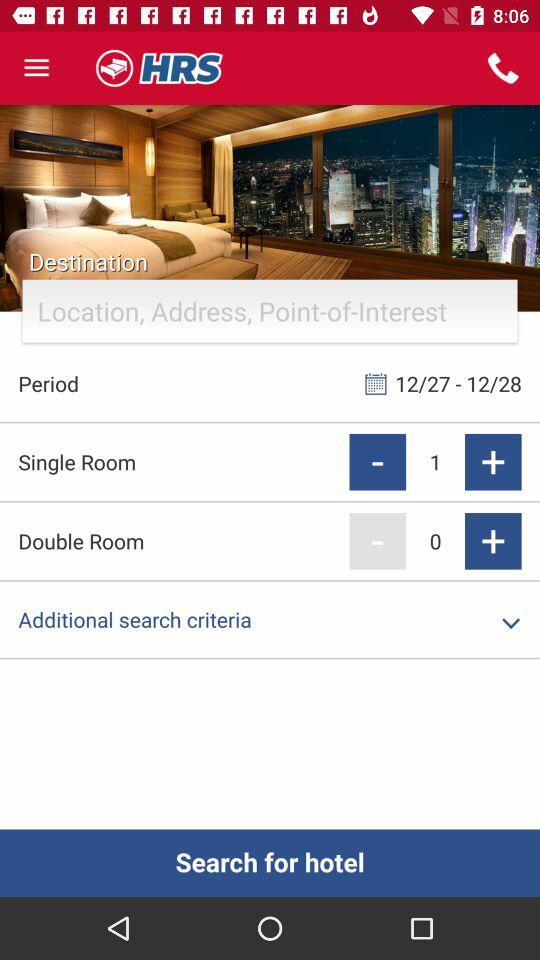How many rooms are being searched for?
Answer the question using a single word or phrase. 1 